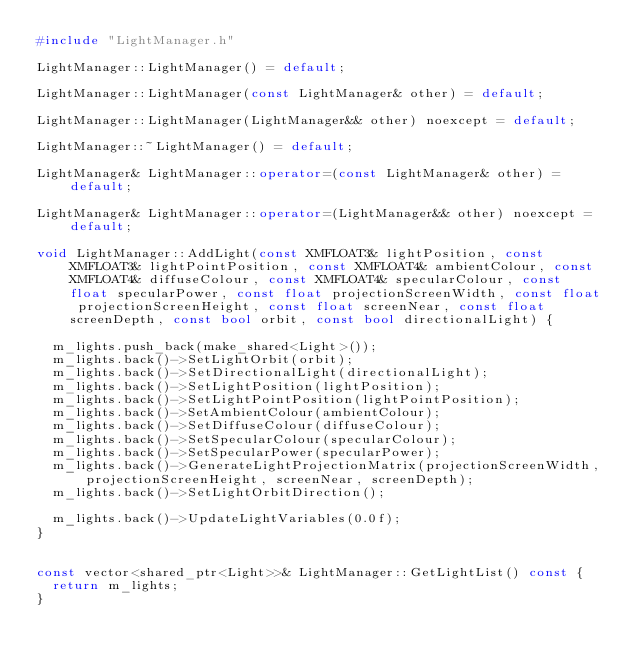Convert code to text. <code><loc_0><loc_0><loc_500><loc_500><_C++_>#include "LightManager.h"

LightManager::LightManager() = default;

LightManager::LightManager(const LightManager& other) = default;

LightManager::LightManager(LightManager&& other) noexcept = default;

LightManager::~LightManager() = default;

LightManager& LightManager::operator=(const LightManager& other) = default;

LightManager& LightManager::operator=(LightManager&& other) noexcept = default;

void LightManager::AddLight(const XMFLOAT3& lightPosition, const XMFLOAT3& lightPointPosition, const XMFLOAT4& ambientColour, const XMFLOAT4& diffuseColour, const XMFLOAT4& specularColour, const float specularPower, const float projectionScreenWidth, const float projectionScreenHeight, const float screenNear, const float screenDepth, const bool orbit, const bool directionalLight) {
	
	m_lights.push_back(make_shared<Light>());
	m_lights.back()->SetLightOrbit(orbit);
	m_lights.back()->SetDirectionalLight(directionalLight);
	m_lights.back()->SetLightPosition(lightPosition);
	m_lights.back()->SetLightPointPosition(lightPointPosition);
	m_lights.back()->SetAmbientColour(ambientColour);
	m_lights.back()->SetDiffuseColour(diffuseColour);
	m_lights.back()->SetSpecularColour(specularColour);
	m_lights.back()->SetSpecularPower(specularPower);
	m_lights.back()->GenerateLightProjectionMatrix(projectionScreenWidth, projectionScreenHeight, screenNear, screenDepth);
	m_lights.back()->SetLightOrbitDirection();

	m_lights.back()->UpdateLightVariables(0.0f);
}


const vector<shared_ptr<Light>>& LightManager::GetLightList() const {
	return m_lights;
}
</code> 